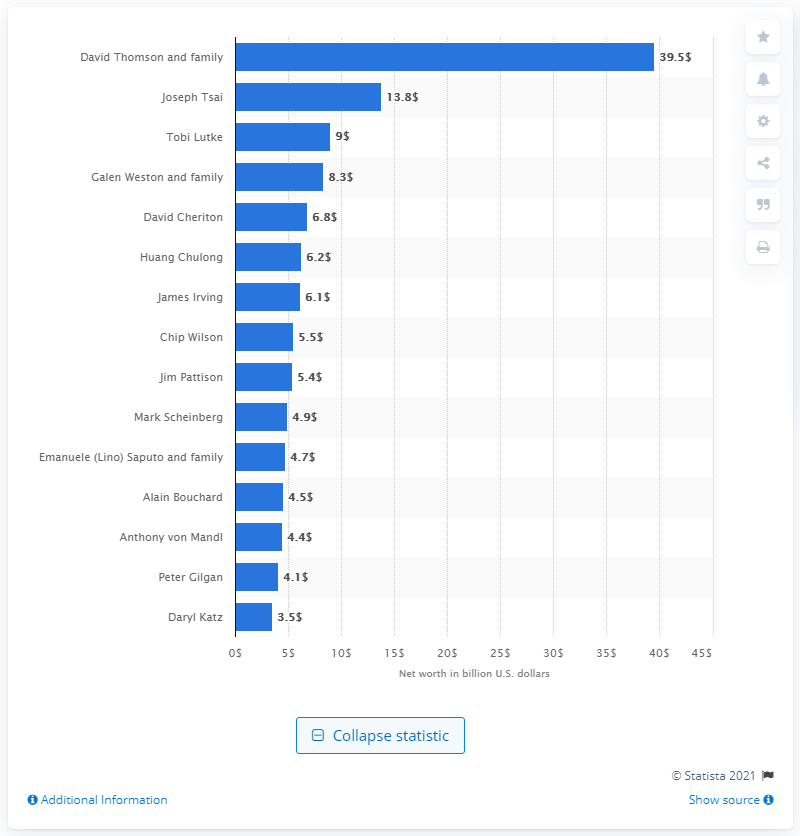Outline some significant characteristics in this image. Joseph Tsai is the second richest person in Canada. 